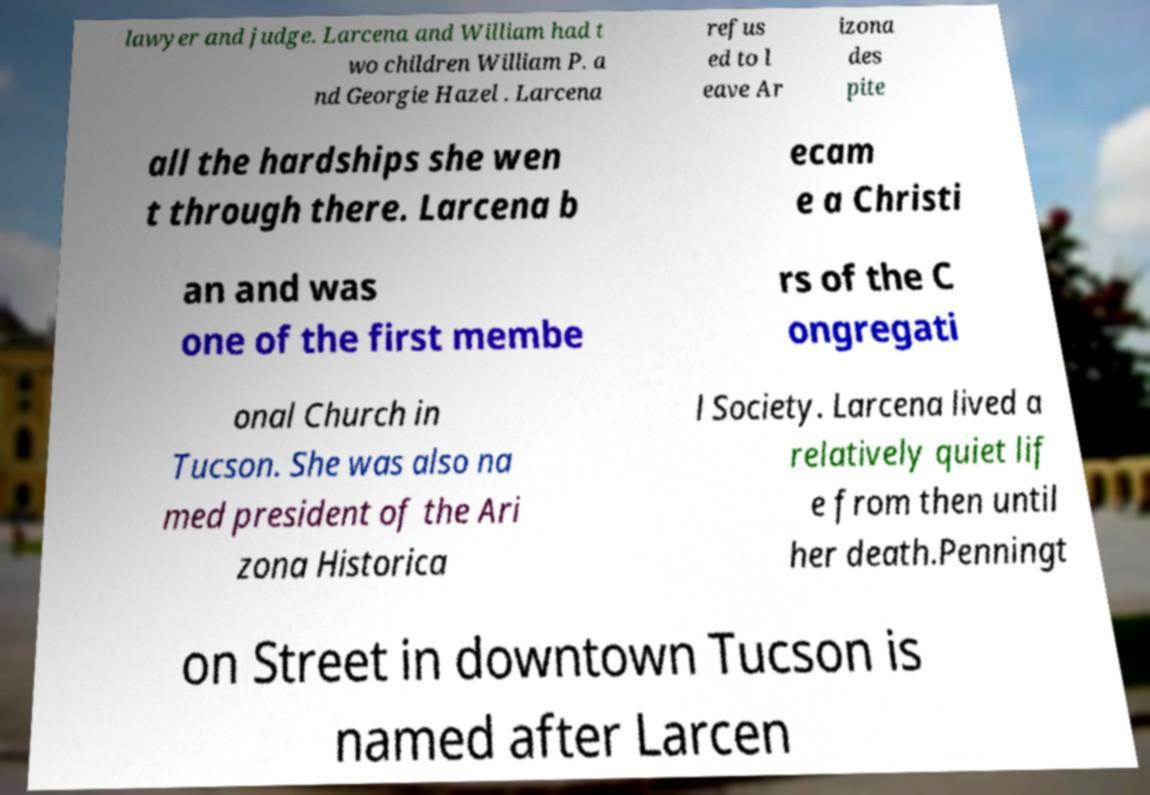There's text embedded in this image that I need extracted. Can you transcribe it verbatim? lawyer and judge. Larcena and William had t wo children William P. a nd Georgie Hazel . Larcena refus ed to l eave Ar izona des pite all the hardships she wen t through there. Larcena b ecam e a Christi an and was one of the first membe rs of the C ongregati onal Church in Tucson. She was also na med president of the Ari zona Historica l Society. Larcena lived a relatively quiet lif e from then until her death.Penningt on Street in downtown Tucson is named after Larcen 